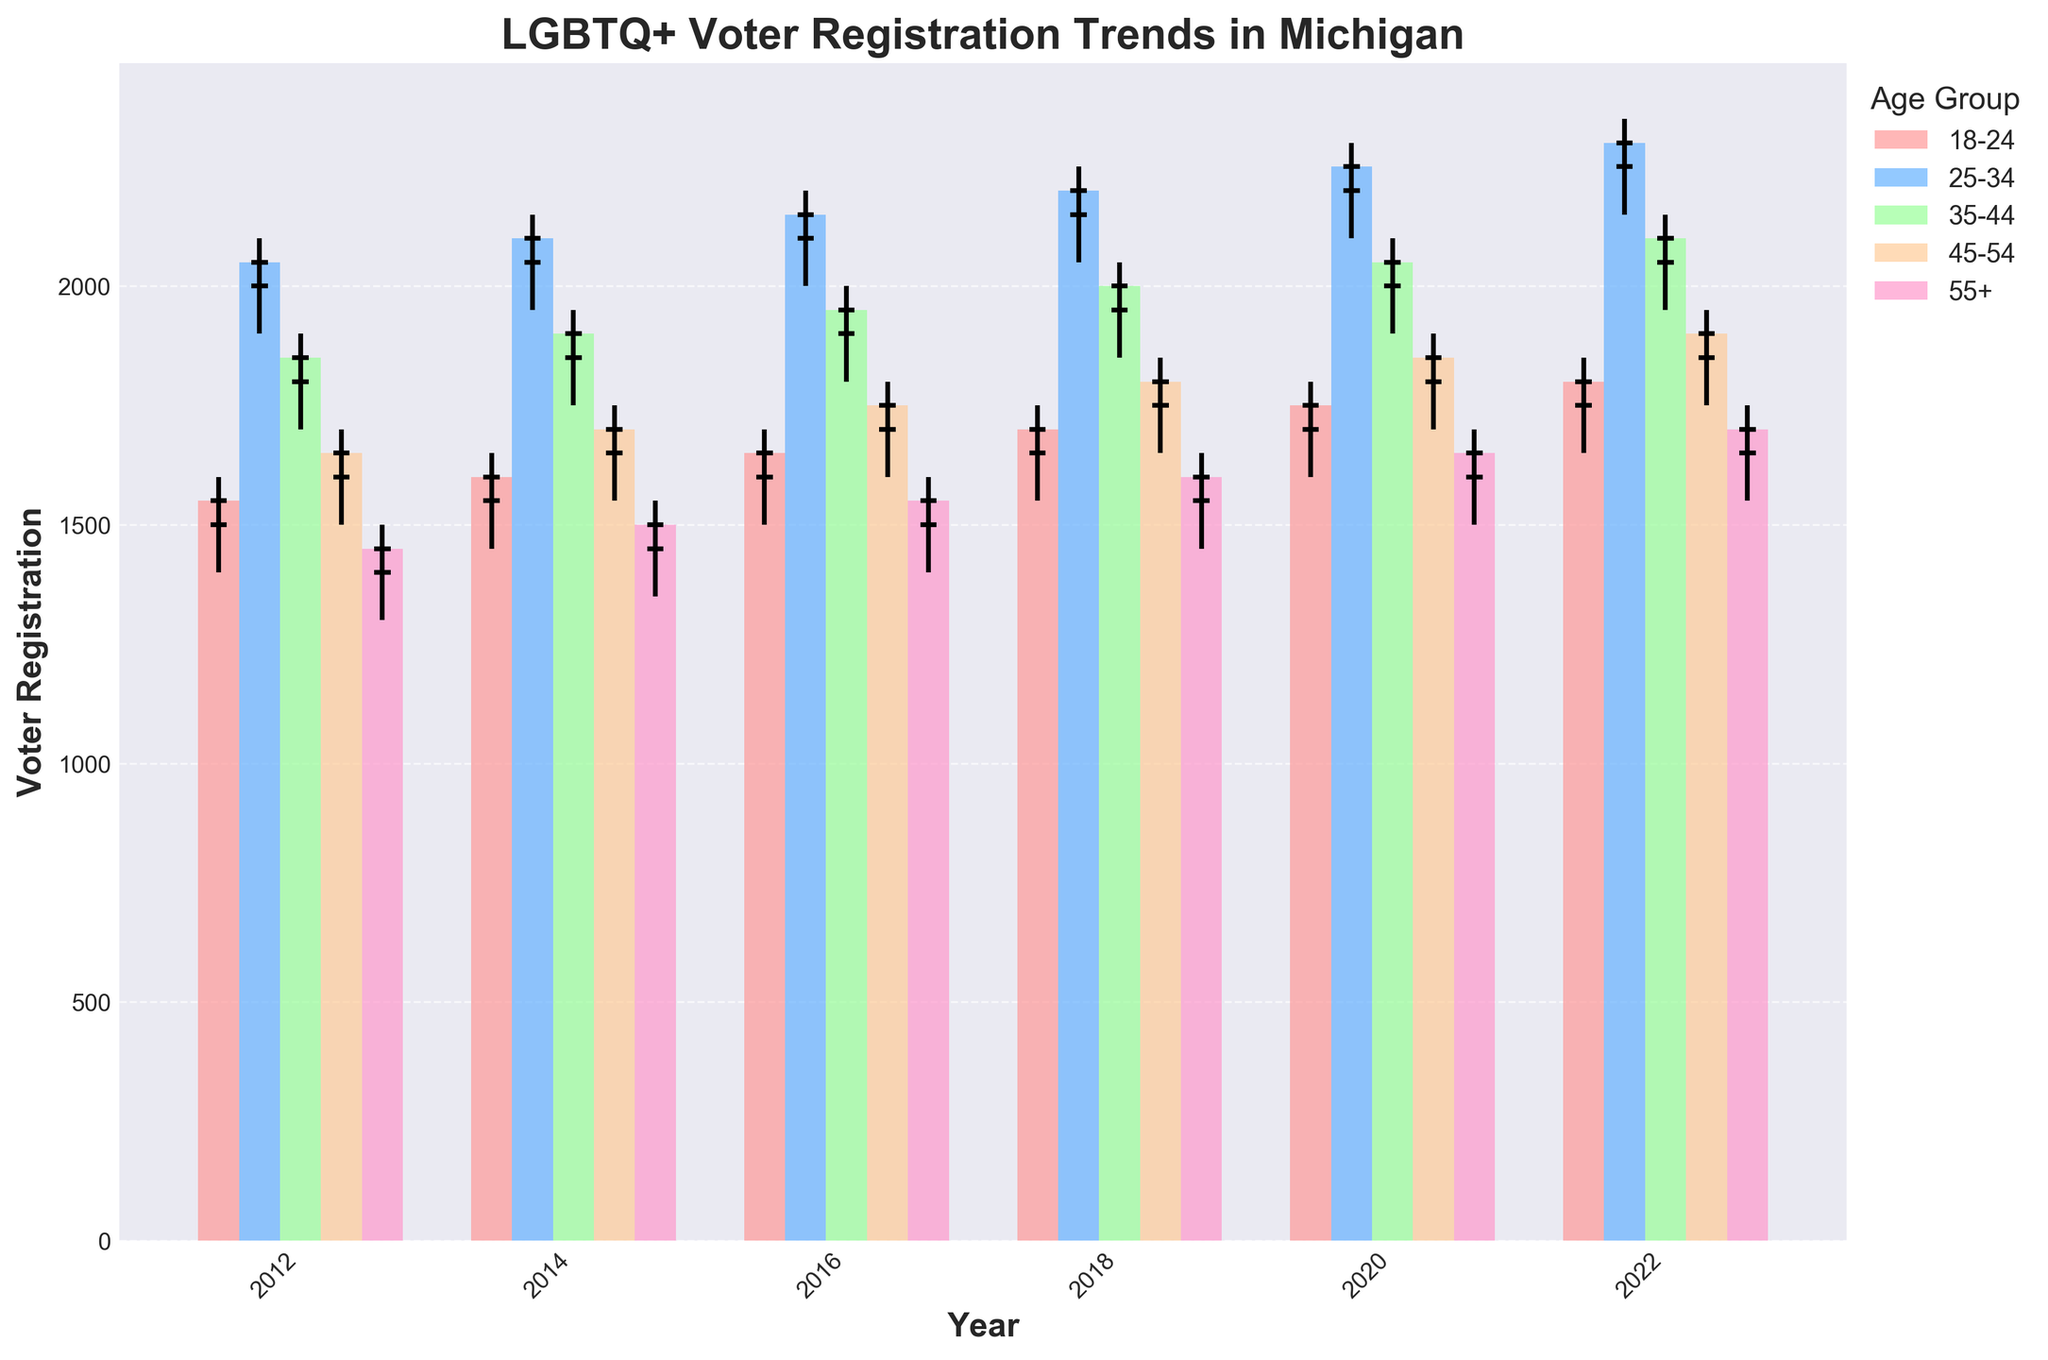what is the title of the figure? The title of the figure is usually placed at the top center of the plot and describes the main subject of the visualization. Here, it reads "LGBTQ+ Voter Registration Trends in Michigan."
Answer: LGBTQ+ Voter Registration Trends in Michigan What is the y-axis label in the figure? The y-axis label is typically used to indicate what is being measured along the vertical axis. In this plot, it is labeled "Voter Registration."
Answer: Voter Registration Which age group had the highest voter registration close value in 2020? To find the highest close value for voter registration in 2020, you look at the bar heights and identify the tallest one for that year. The age group 25-34 has the highest close value of 2250 in 2020.
Answer: 25-34 How did voter registration for the age group 55+ compare between 2014 and 2022? To compare voter registration for the 55+ age group between 2014 and 2022, look at the height of the bars and endpoints of the candlesticks. In 2014, the close value was 1500, and in 2022, it was 1700, indicating an increase over the years.
Answer: Increased What is the overall trend observed in voter registration for the 18-24 age group from 2012 to 2022? To deduce the overall trend, observe the changes in the bar heights and candlestick positions for the 18-24 age group each year. The close values increased from 1550 in 2012 to 1800 in 2022, indicating an upward trend.
Answer: Upward trend Compare the high values in the year 2016 for the 25-34 and 35-44 age groups. Which one is greater? Comparing the highest points of the candlesticks for 25-34 and 35-44 age groups in 2016, the 25-34 age group has a high value of 2200, whereas the 35-44 age group has a high value of 2000. Thus, 25-34 is greater.
Answer: 25-34 How does the close value for the 45-54 age group in 2018 compare to its open value? Observing the candlestick for the 45-54 age group in 2018, the open value is 1750 and the close value is 1800. The close value is higher than the open value.
Answer: Higher What is the difference in the close values between the age groups 18-24 and 55+ in 2020? To find the difference, subtract the close value of the 55+ age group from the close value of the 18-24 age group in 2020. This is 1750 (18-24) - 1650 (55+) = 100.
Answer: 100 Which age group showed a decline in voter registration close values from 2018 to 2020? To identify the age group with declining voter registration, compare the close values for each group from 2018 to 2020. The 25-34 age group had a close value of 2200 in 2018 and 2250 in 2020, while the rest showed an increase or remained the same. Thus, no age group showed a decline.
Answer: None 